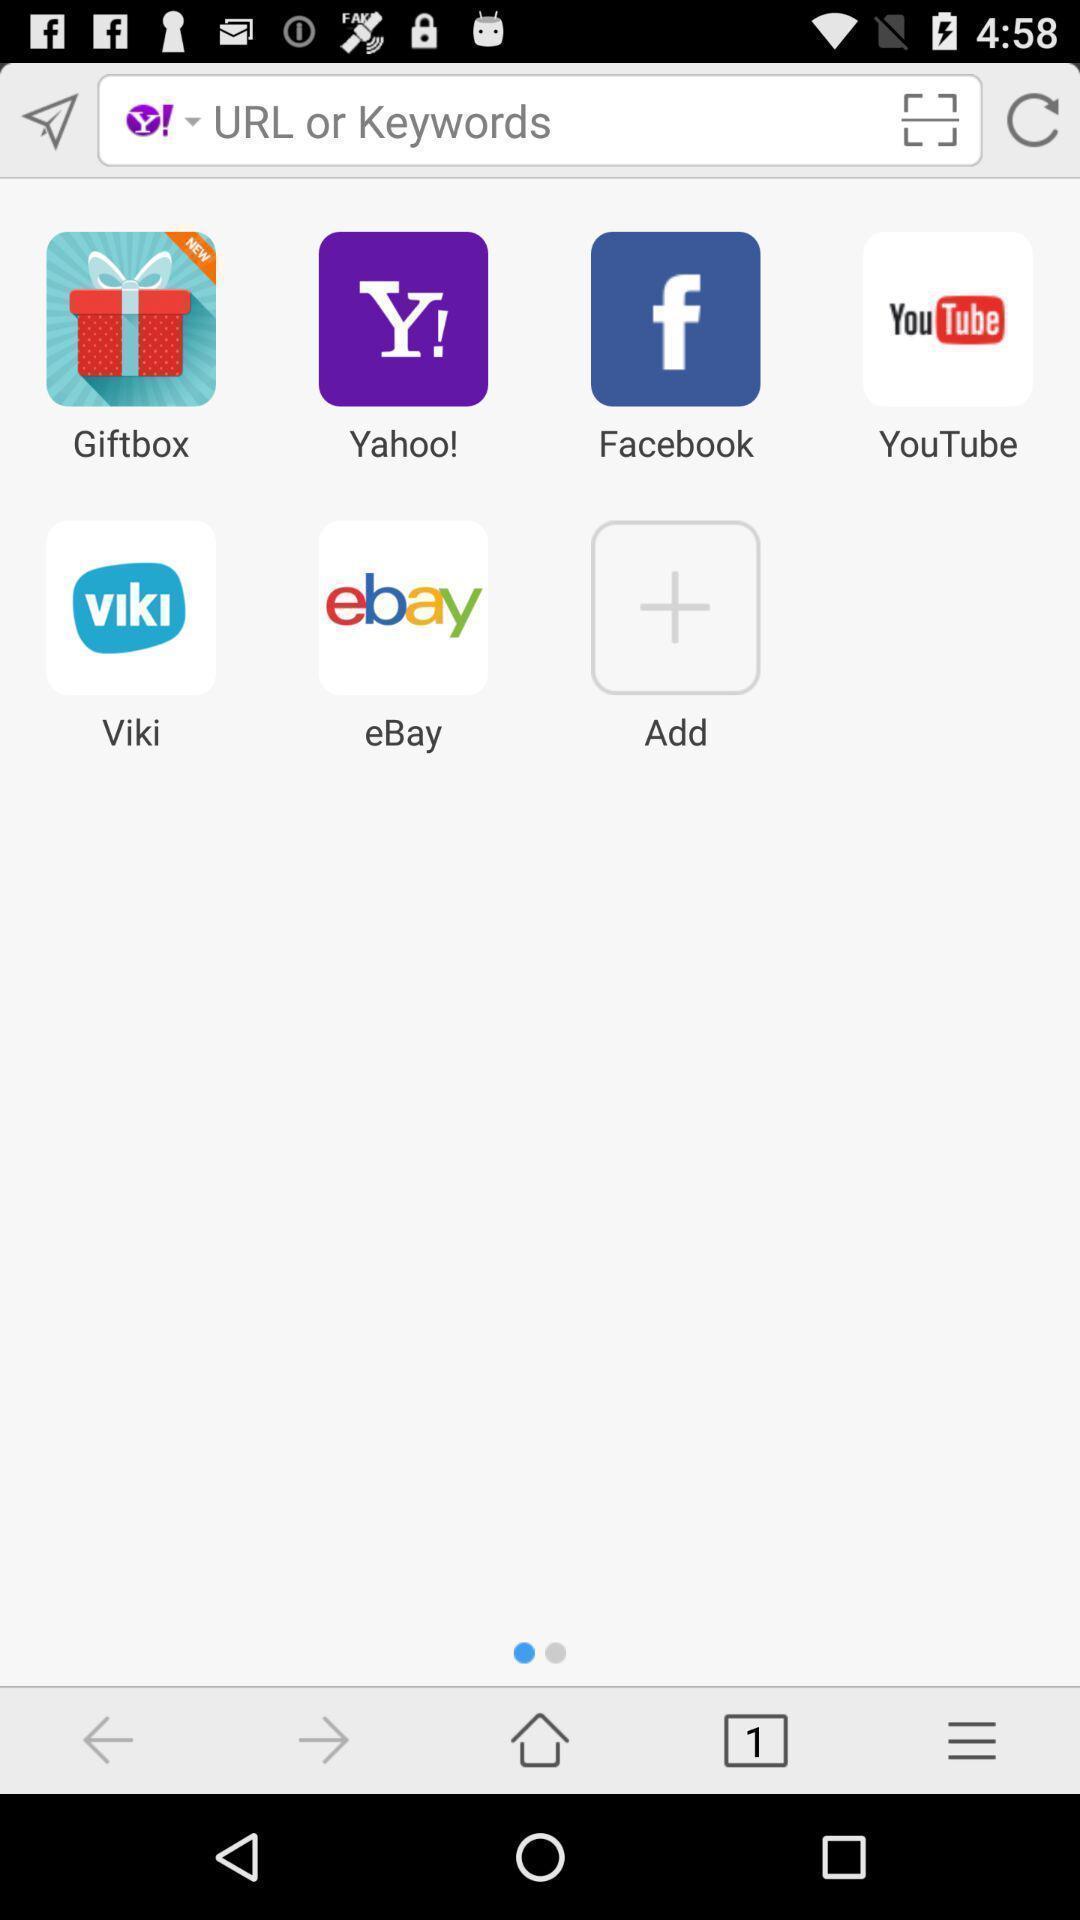Please provide a description for this image. Search bar with multiple suggestions. 